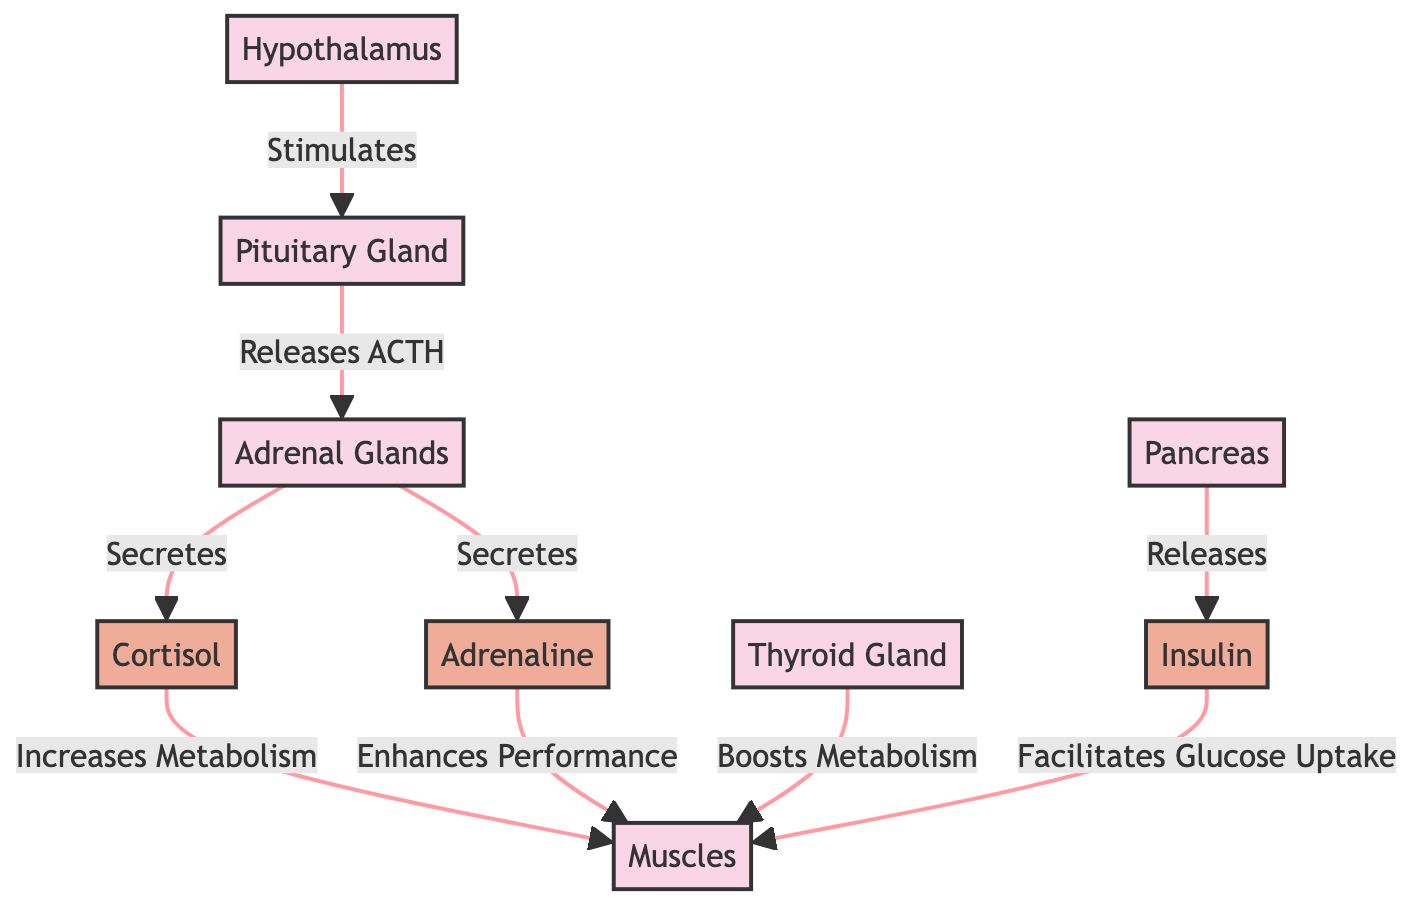What hormone is released by the adrenal glands in response to physical activity? The diagram shows that the adrenal glands secrete adrenaline in response to stimuli, highlighting its role in physical activity.
Answer: Adrenaline How many organs are involved in the hormonal response to physical activity? The diagram lists six organs: hypothalamus, pituitary gland, adrenal glands, thyroid gland, pancreas, and muscles. Counting these provides the answer.
Answer: 6 What does cortisol increase in muscles? The diagram indicates that cortisol's role is to increase metabolism in the muscles during physical activity.
Answer: Metabolism Which gland boosts metabolism alongside cortisol? The diagram shows that the thyroid gland boosts metabolism, working in coordination with cortisol during physical activity.
Answer: Thyroid Gland What is the function of insulin in relation to muscles? According to the diagram, insulin facilitates glucose uptake in muscles, which is crucial for energy during physical activity.
Answer: Facilitates Glucose Uptake What signals the adrenal glands to release cortisol? The diagram indicates that the pituitary gland releases ACTH, which signals the adrenal glands to secrete cortisol.
Answer: ACTH What effect does adrenaline have on muscles? The diagram outlines that adrenaline enhances performance in the muscles, indicating its positive effects during physical activity.
Answer: Enhances Performance Which gland is at the top of the hormonal response process? The diagram identifies the hypothalamus as the starting point that stimulates the next gland in the response pathway.
Answer: Hypothalamus What role does the pancreas play in the hormonal response? The diagram shows that the pancreas releases insulin, which is essential for managing glucose levels in the body during physical activity.
Answer: Releases Insulin 